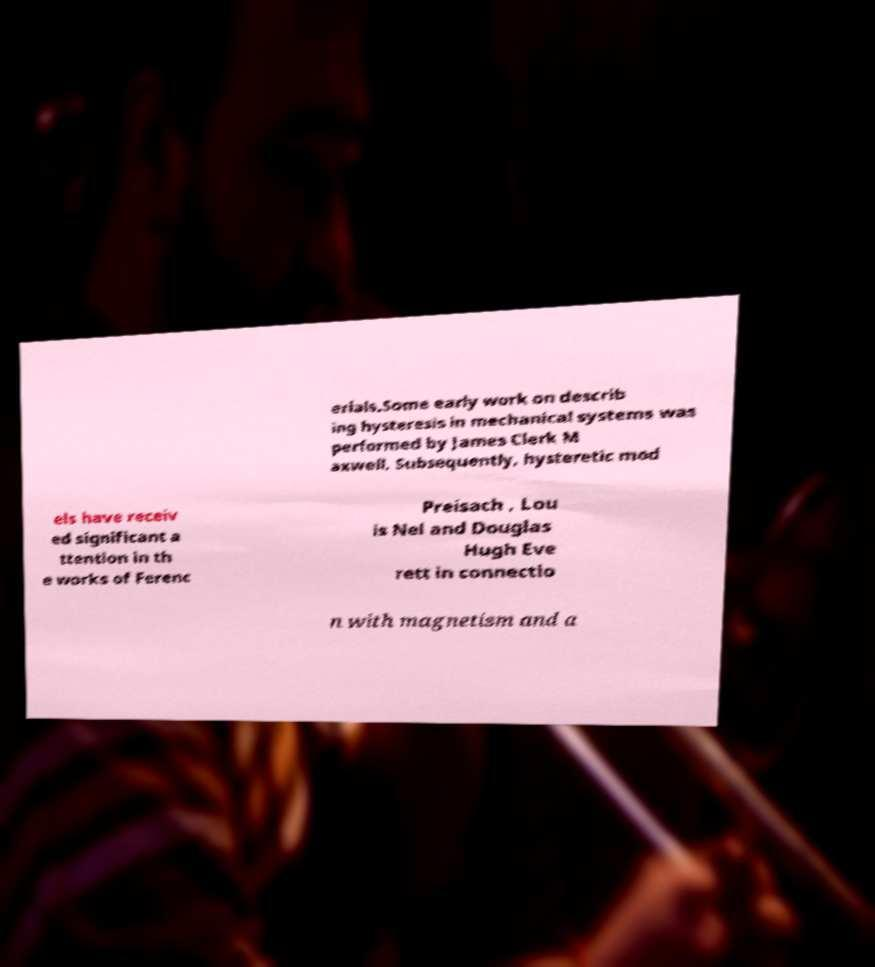I need the written content from this picture converted into text. Can you do that? erials.Some early work on describ ing hysteresis in mechanical systems was performed by James Clerk M axwell. Subsequently, hysteretic mod els have receiv ed significant a ttention in th e works of Ferenc Preisach , Lou is Nel and Douglas Hugh Eve rett in connectio n with magnetism and a 